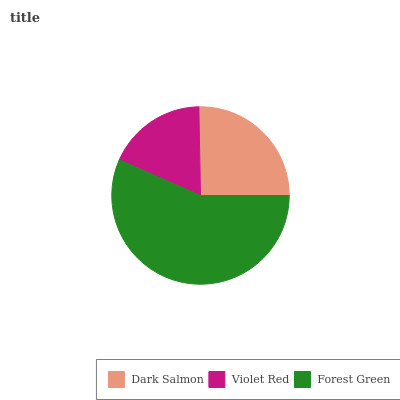Is Violet Red the minimum?
Answer yes or no. Yes. Is Forest Green the maximum?
Answer yes or no. Yes. Is Forest Green the minimum?
Answer yes or no. No. Is Violet Red the maximum?
Answer yes or no. No. Is Forest Green greater than Violet Red?
Answer yes or no. Yes. Is Violet Red less than Forest Green?
Answer yes or no. Yes. Is Violet Red greater than Forest Green?
Answer yes or no. No. Is Forest Green less than Violet Red?
Answer yes or no. No. Is Dark Salmon the high median?
Answer yes or no. Yes. Is Dark Salmon the low median?
Answer yes or no. Yes. Is Forest Green the high median?
Answer yes or no. No. Is Violet Red the low median?
Answer yes or no. No. 